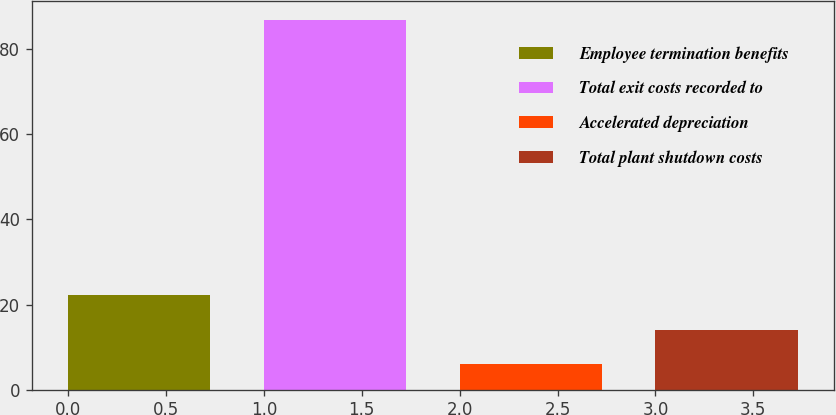<chart> <loc_0><loc_0><loc_500><loc_500><bar_chart><fcel>Employee termination benefits<fcel>Total exit costs recorded to<fcel>Accelerated depreciation<fcel>Total plant shutdown costs<nl><fcel>22.2<fcel>87<fcel>6<fcel>14.1<nl></chart> 